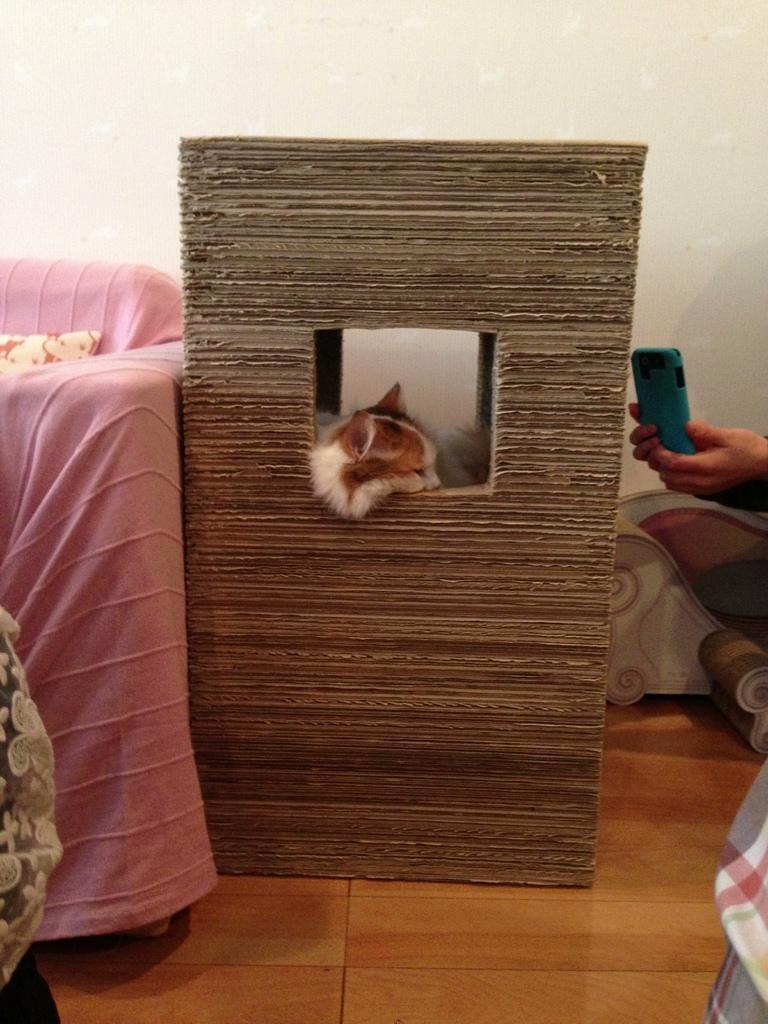Can you describe this image briefly? There is a cat sitting in a box. On the left side, there is a pink color cloth on an object. On the right side, there is a person holding a mobile. In the background, there is white wall. 